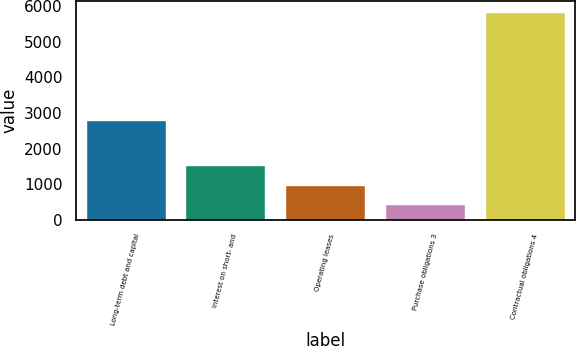<chart> <loc_0><loc_0><loc_500><loc_500><bar_chart><fcel>Long-term debt and capital<fcel>Interest on short- and<fcel>Operating leases<fcel>Purchase obligations 3<fcel>Contractual obligations 4<nl><fcel>2794<fcel>1529.2<fcel>989.6<fcel>450<fcel>5846<nl></chart> 